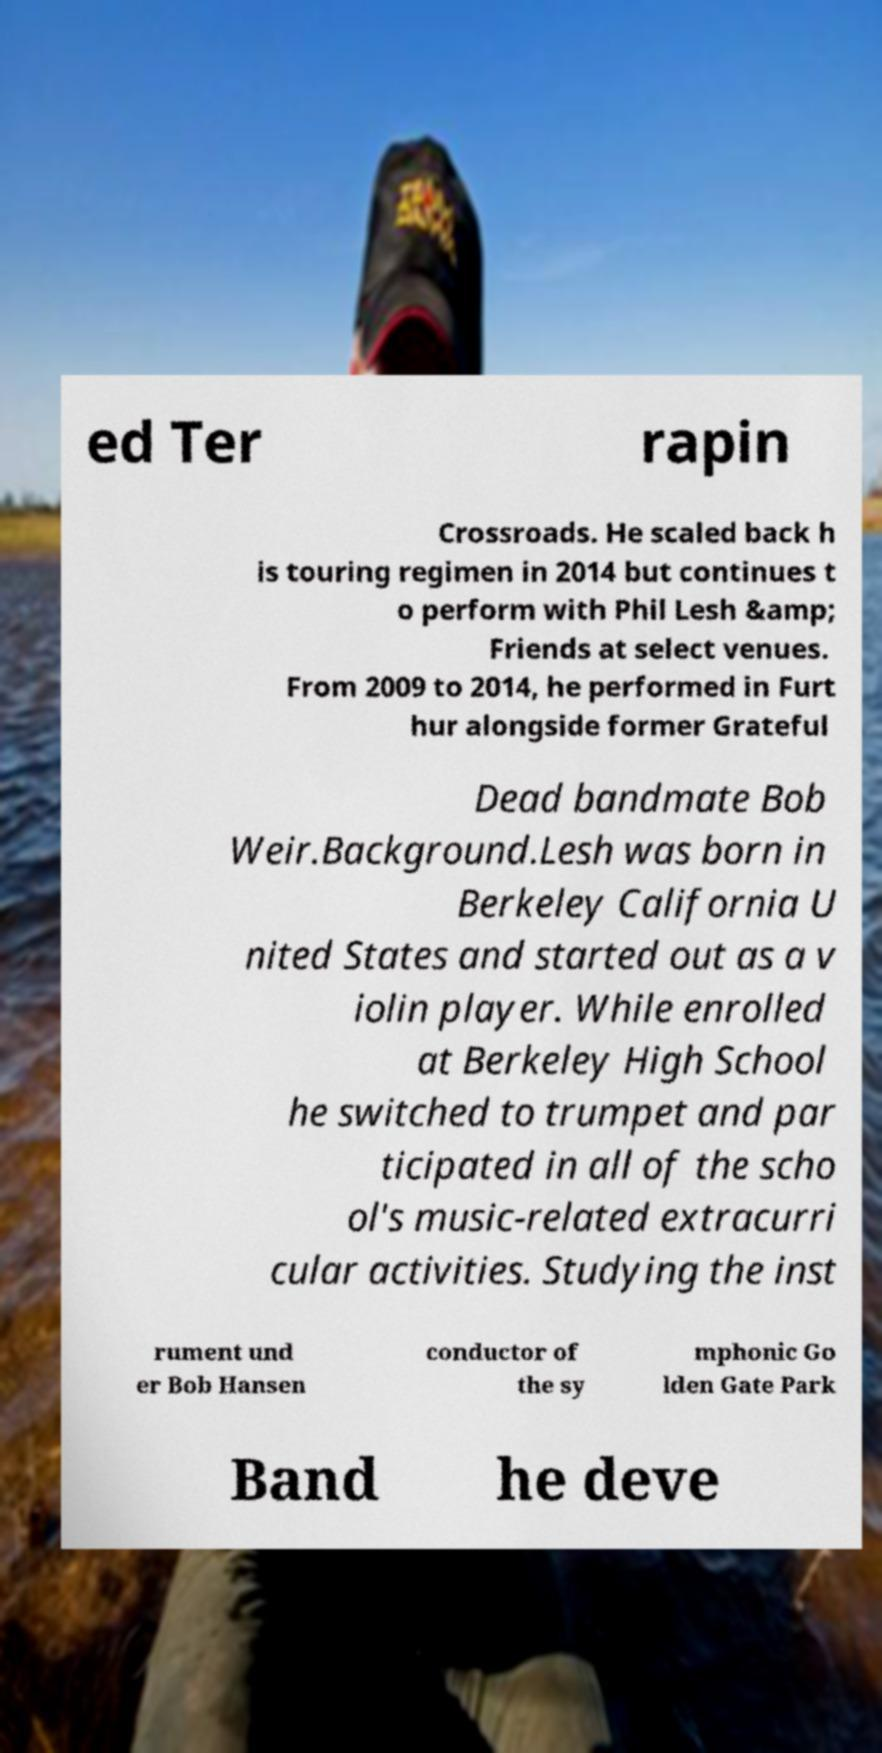Could you extract and type out the text from this image? ed Ter rapin Crossroads. He scaled back h is touring regimen in 2014 but continues t o perform with Phil Lesh &amp; Friends at select venues. From 2009 to 2014, he performed in Furt hur alongside former Grateful Dead bandmate Bob Weir.Background.Lesh was born in Berkeley California U nited States and started out as a v iolin player. While enrolled at Berkeley High School he switched to trumpet and par ticipated in all of the scho ol's music-related extracurri cular activities. Studying the inst rument und er Bob Hansen conductor of the sy mphonic Go lden Gate Park Band he deve 